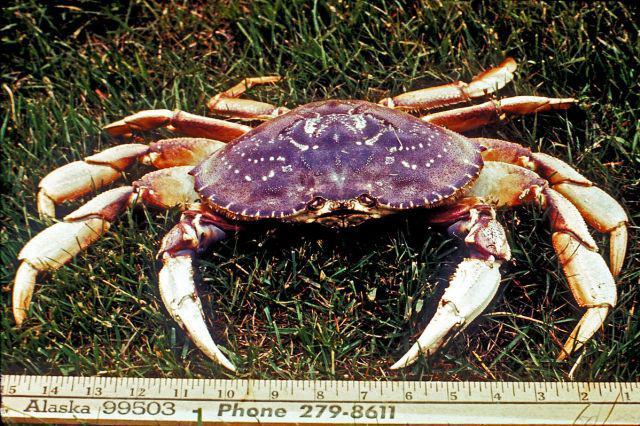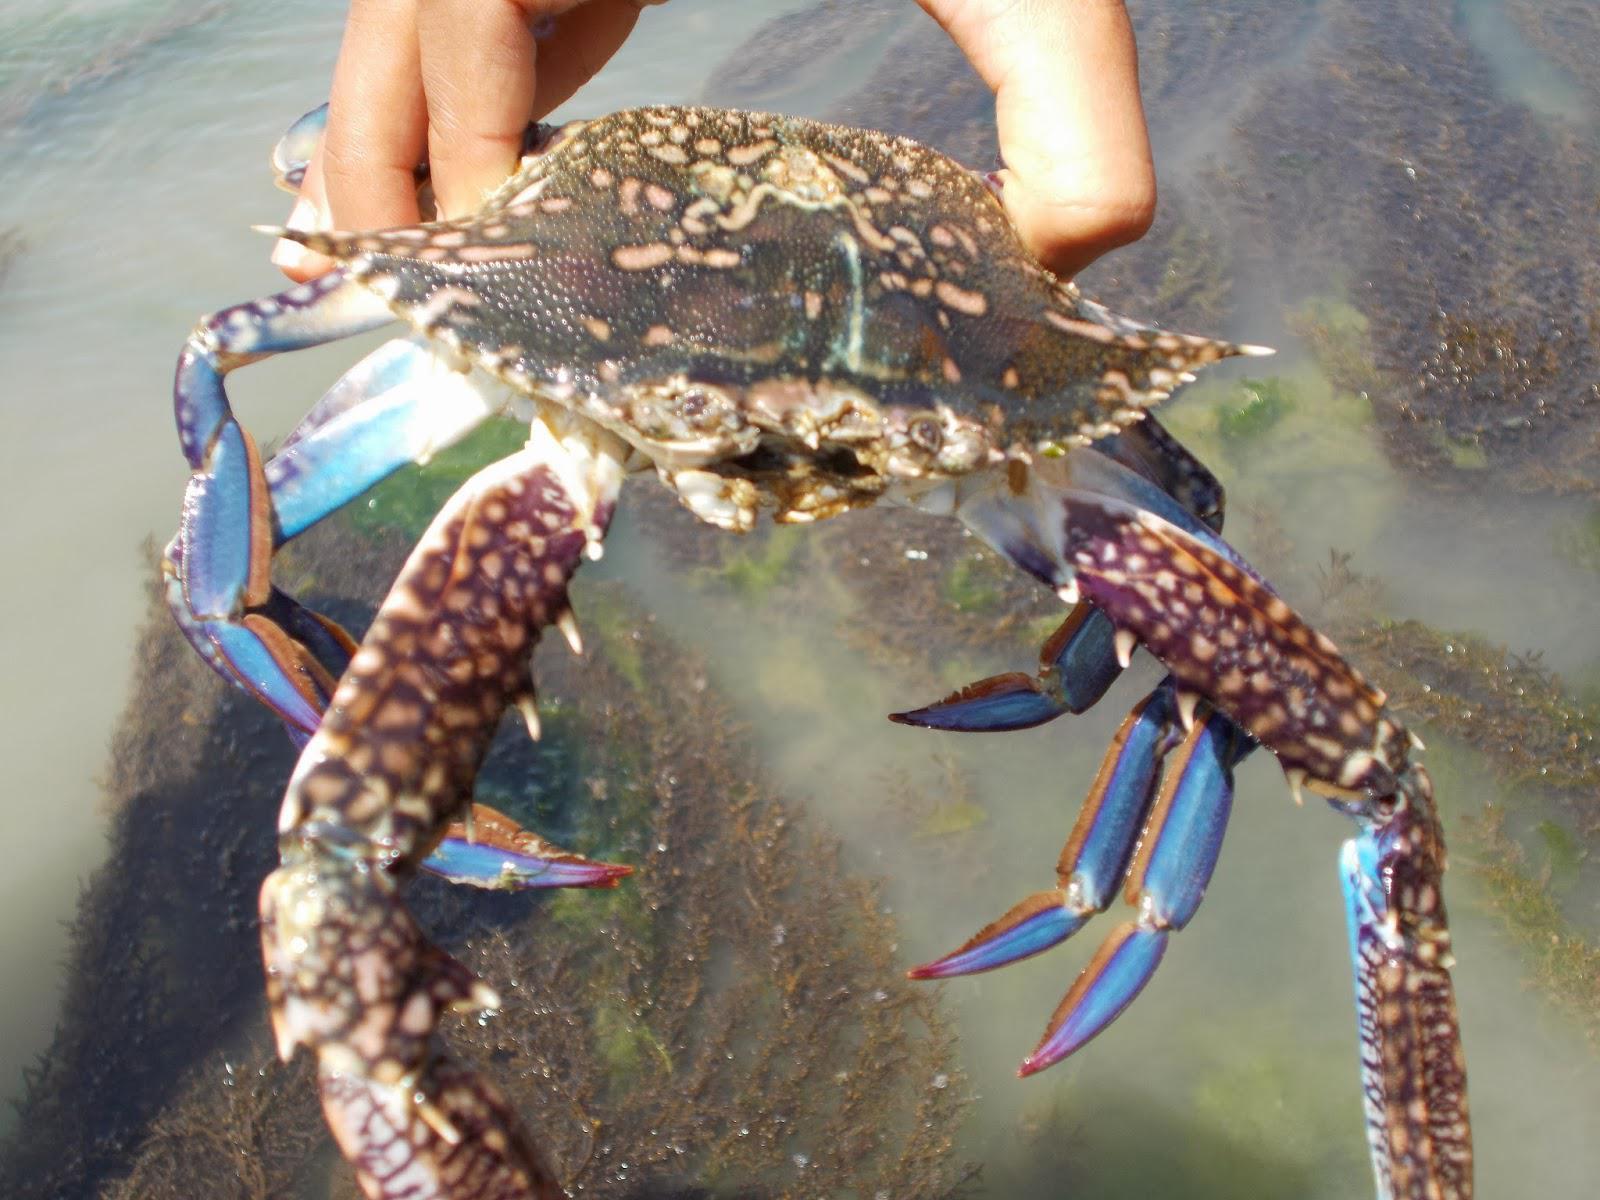The first image is the image on the left, the second image is the image on the right. Examine the images to the left and right. Is the description "In at least one image there is a single purple headed crab crawling in the ground." accurate? Answer yes or no. Yes. The first image is the image on the left, the second image is the image on the right. Analyze the images presented: Is the assertion "One image shows one forward-facing crab with a bright purple shell, and no image contains more than two crabs." valid? Answer yes or no. Yes. 